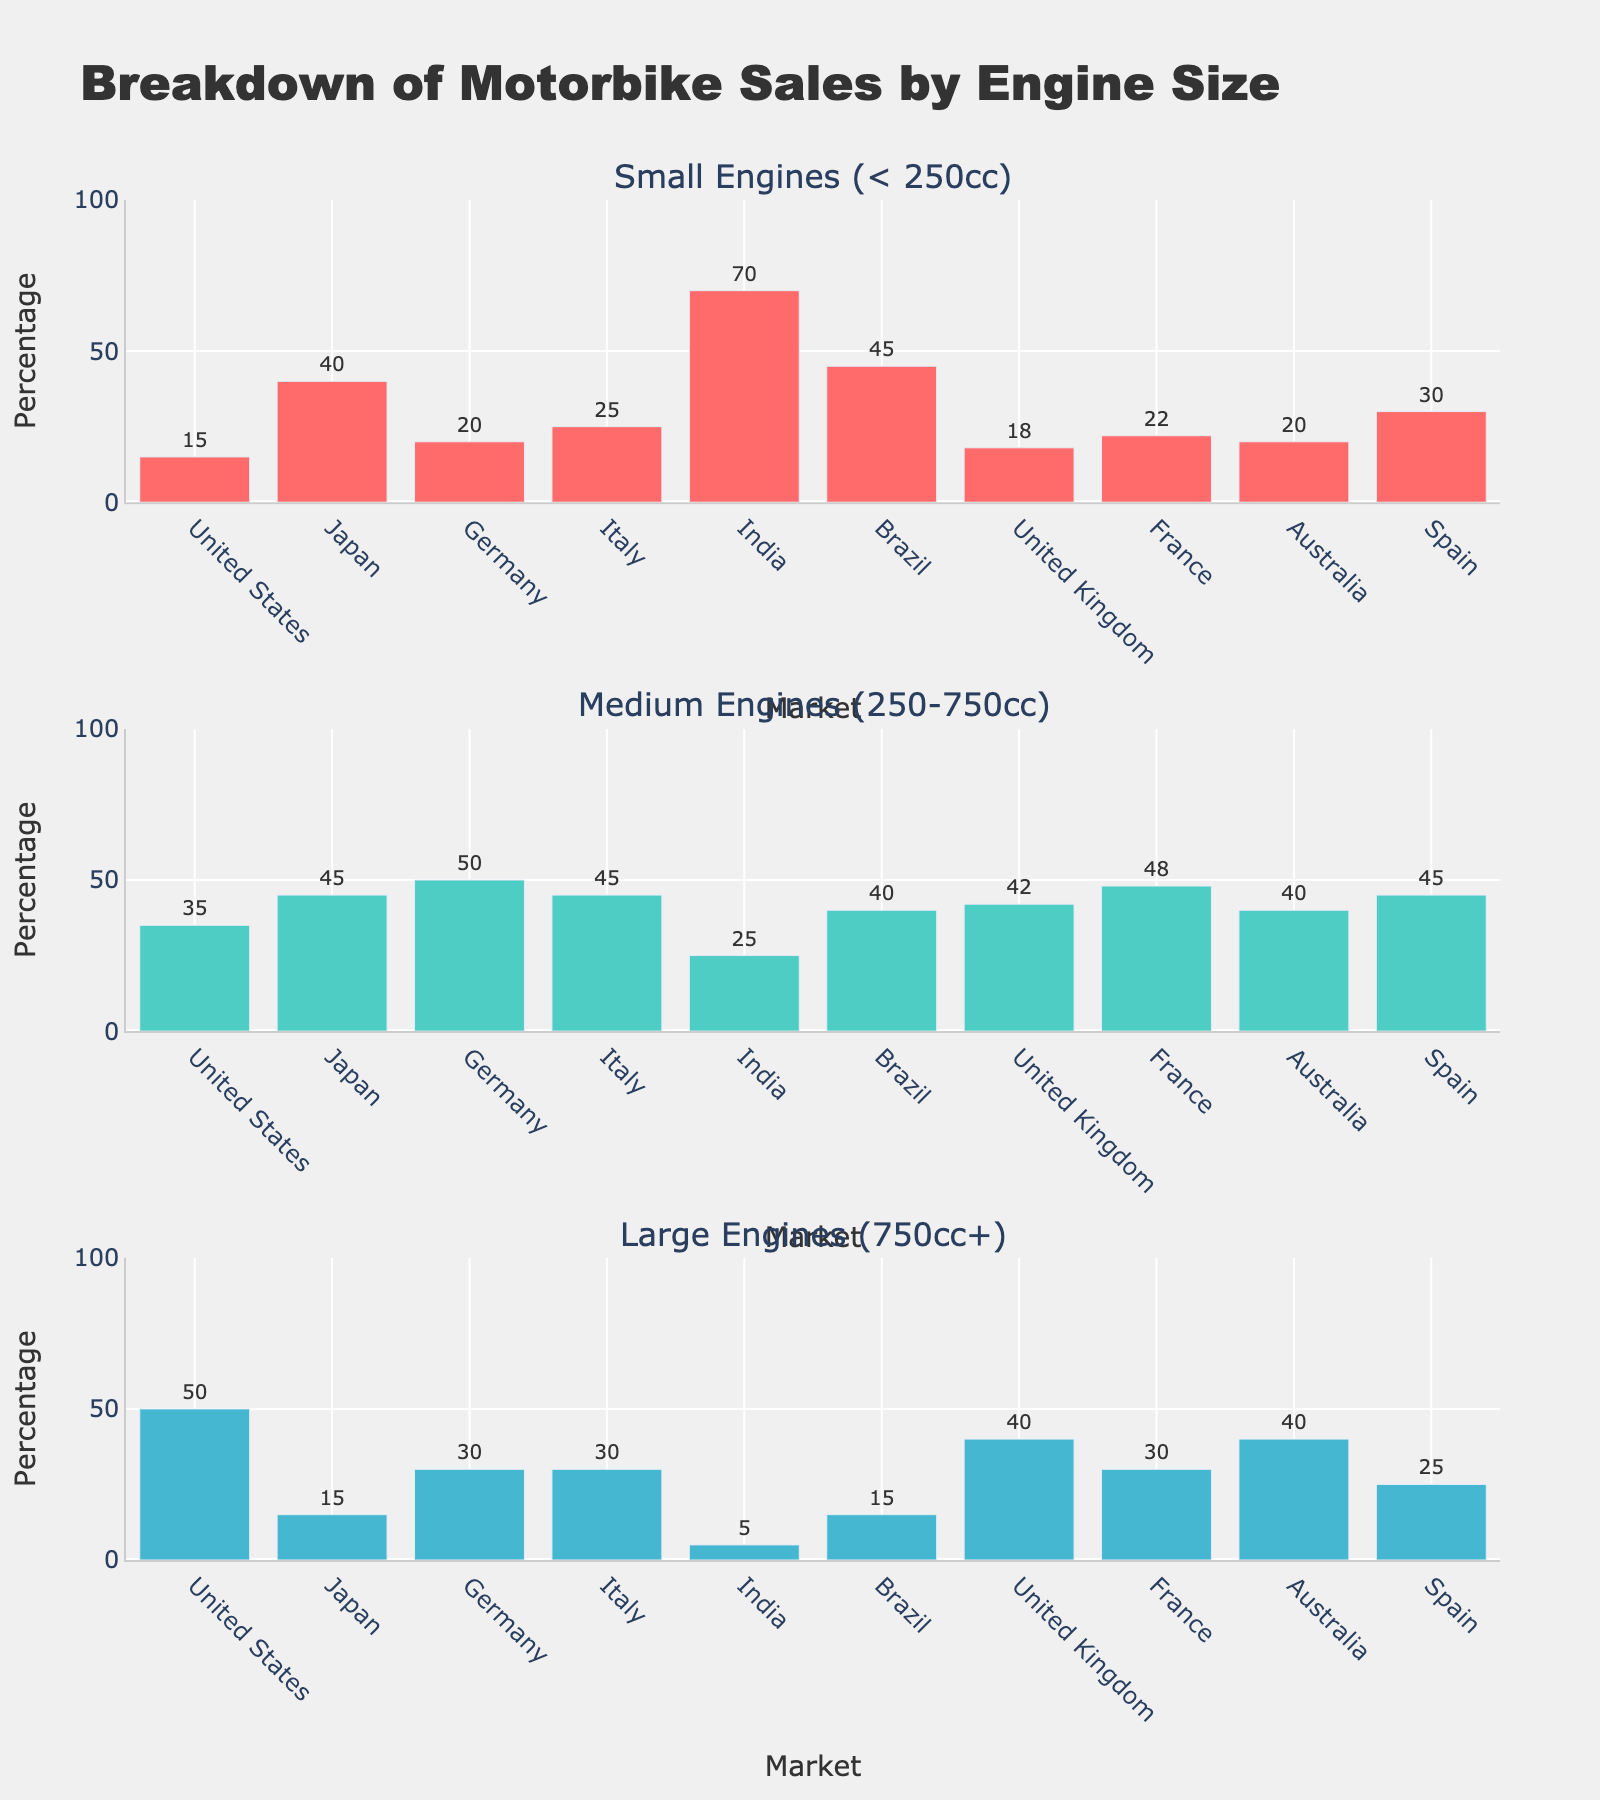What's the title of the figure? The title of the figure is displayed at the top center, and it summarizes what the figure is about.
Answer: Breakdown of Motorbike Sales by Engine Size Which market has the highest percentage of small engine motorbike sales? Looking at the first subplot (Small Engines), the bar for India is the highest, indicating the highest percentage in small engine sales.
Answer: India What's the percentage of medium engine motorbike sales in Germany? In the second subplot (Medium Engines), the bar labeled Germany reaches the 50% mark on the y-axis.
Answer: 50% How many subplots are there in the figure? The layout of the figure shows three distinct sections, each corresponding to a different engine size category.
Answer: 3 Which market has the lowest percentage of large engine motorbike sales? In the third subplot (Large Engines), the bar for India is the shortest, indicating the lowest percentage in large engine sales.
Answer: India Compare the percentage of medium and large engine sales in the United Kingdom. Which is higher? In the United Kingdom, the medium engine sales percentage is represented by a bar at 42%, while the large engine sales percentage is represented by a bar at 40%.
Answer: Medium (42%) What is the combined percentage of small engine sales in Japan and Brazil? From the first subplot, Japan has 40% and Brazil has 45%, combining these gives 40 + 45.
Answer: 85% Which market shows an equal percentage for medium and large engine motorbike sales? In the United States, the bars for both medium and large engine sales reach the 35% mark on the second and third subplots respectively.
Answer: United States How does the percentage of small engine sales in Italy compare to that in Spain? In the first subplot, the bar for Italy reaches 25%, while the bar for Spain reaches 30%, indicating higher sales in Spain.
Answer: Spain What's the average percentage of large engine sales in the United States, United Kingdom, and Australia? Sum the percentages from the third subplot: United States (50%), United Kingdom (40%), Australia (40%). Then divide by 3: (50 + 40 + 40) / 3.
Answer: 43.33% 